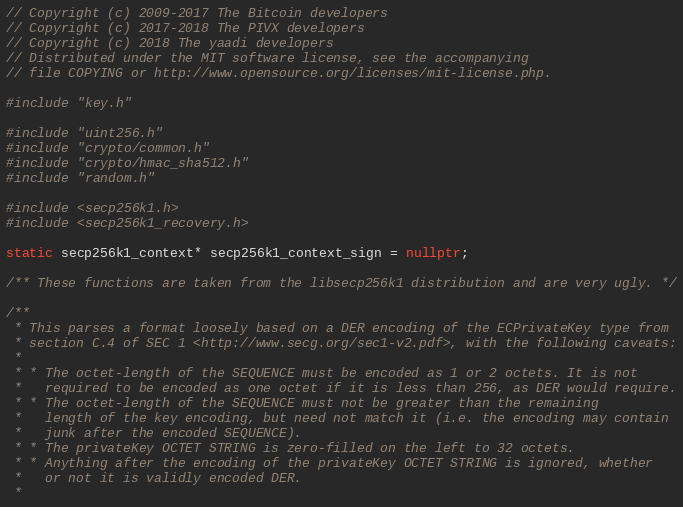<code> <loc_0><loc_0><loc_500><loc_500><_C++_>// Copyright (c) 2009-2017 The Bitcoin developers
// Copyright (c) 2017-2018 The PIVX developers
// Copyright (c) 2018 The yaadi developers
// Distributed under the MIT software license, see the accompanying
// file COPYING or http://www.opensource.org/licenses/mit-license.php.

#include "key.h"

#include "uint256.h"
#include "crypto/common.h"
#include "crypto/hmac_sha512.h"
#include "random.h"

#include <secp256k1.h>
#include <secp256k1_recovery.h>

static secp256k1_context* secp256k1_context_sign = nullptr;

/** These functions are taken from the libsecp256k1 distribution and are very ugly. */

/**
 * This parses a format loosely based on a DER encoding of the ECPrivateKey type from
 * section C.4 of SEC 1 <http://www.secg.org/sec1-v2.pdf>, with the following caveats:
 *
 * * The octet-length of the SEQUENCE must be encoded as 1 or 2 octets. It is not
 *   required to be encoded as one octet if it is less than 256, as DER would require.
 * * The octet-length of the SEQUENCE must not be greater than the remaining
 *   length of the key encoding, but need not match it (i.e. the encoding may contain
 *   junk after the encoded SEQUENCE).
 * * The privateKey OCTET STRING is zero-filled on the left to 32 octets.
 * * Anything after the encoding of the privateKey OCTET STRING is ignored, whether
 *   or not it is validly encoded DER.
 *</code> 